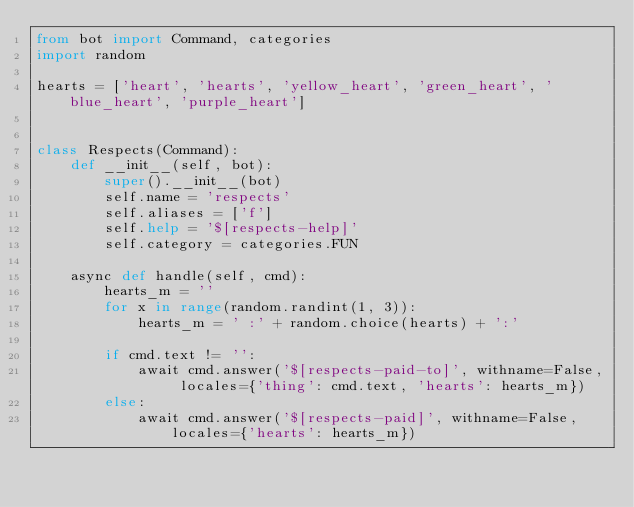<code> <loc_0><loc_0><loc_500><loc_500><_Python_>from bot import Command, categories
import random

hearts = ['heart', 'hearts', 'yellow_heart', 'green_heart', 'blue_heart', 'purple_heart']


class Respects(Command):
    def __init__(self, bot):
        super().__init__(bot)
        self.name = 'respects'
        self.aliases = ['f']
        self.help = '$[respects-help]'
        self.category = categories.FUN

    async def handle(self, cmd):
        hearts_m = ''
        for x in range(random.randint(1, 3)):
            hearts_m = ' :' + random.choice(hearts) + ':'

        if cmd.text != '':
            await cmd.answer('$[respects-paid-to]', withname=False, locales={'thing': cmd.text, 'hearts': hearts_m})
        else:
            await cmd.answer('$[respects-paid]', withname=False, locales={'hearts': hearts_m})
</code> 